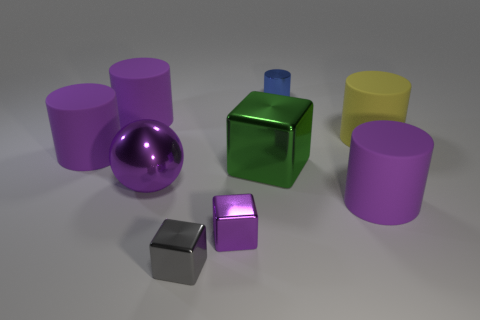Subtract all gray blocks. How many purple cylinders are left? 3 Subtract all blue cylinders. How many cylinders are left? 4 Subtract all metallic cylinders. How many cylinders are left? 4 Subtract all blue cylinders. Subtract all green blocks. How many cylinders are left? 4 Add 1 tiny blue cylinders. How many objects exist? 10 Subtract all cylinders. How many objects are left? 4 Subtract 1 yellow cylinders. How many objects are left? 8 Subtract all purple balls. Subtract all big green balls. How many objects are left? 8 Add 1 purple spheres. How many purple spheres are left? 2 Add 4 yellow cylinders. How many yellow cylinders exist? 5 